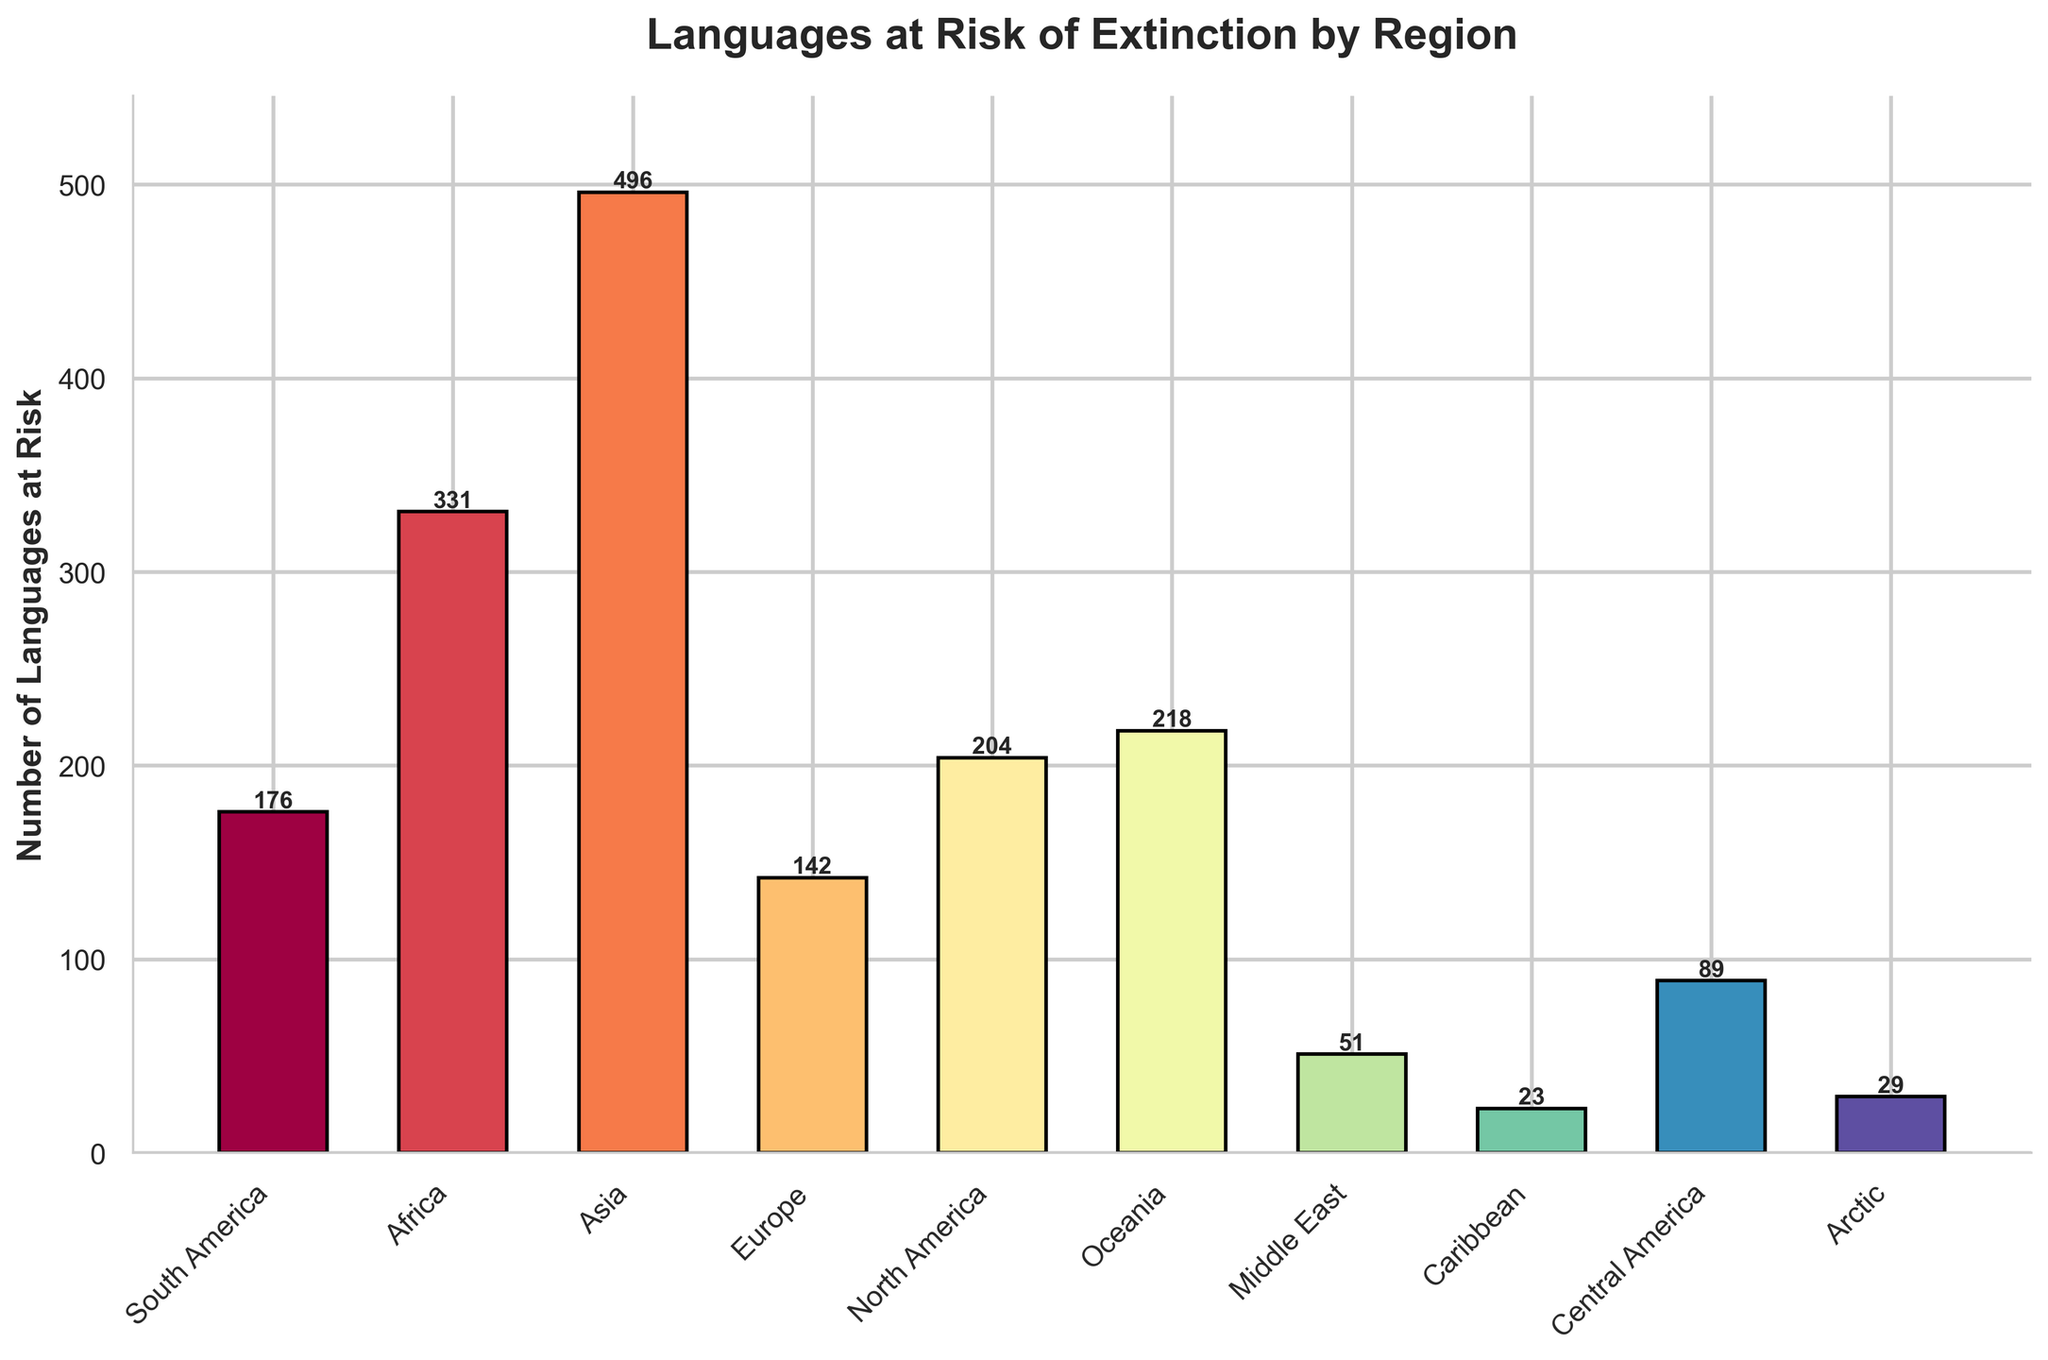Which region has the highest number of languages at risk of extinction? By analyzing the height of the bars in the chart, it is clear that Asia has the tallest bar representing the highest number of languages at risk.
Answer: Asia Which region has the lowest number of languages at risk of extinction? Among all the bars, the Caribbean region has the shortest bar, indicating it has the lowest number of languages at risk.
Answer: Caribbean How many more languages at risk are there in North America compared to Europe? The bar for North America reaches 204, and the bar for Europe reaches 142. Subtracting Europe’s number (142) from North America’s number (204) gives us 204 - 142 = 62.
Answer: 62 What is the total number of languages at risk in South America, Europe, and the Caribbean combined? By summing the number of languages at risk in South America (176), Europe (142), and the Caribbean (23), we get 176 + 142 + 23 = 341.
Answer: 341 How many regions have fewer than 100 languages at risk of extinction? By examining the heights of the bars, the regions with fewer than 100 languages at risk are the Middle East (51), the Caribbean (23), Central America (89), and the Arctic (29). That’s four regions.
Answer: 4 Which region has approximately twice the number of languages at risk as Europe? The number of languages at risk for Europe is 142. Approximately twice this number is 284. Among the listed regions, Africa has 331 languages at risk, which is closest to twice the number in Europe.
Answer: Africa What is the sum of languages at risk in Oceania and the Arctic? By adding the number of languages at risk in Oceania (218) and the Arctic (29), we get 218 + 29 = 247.
Answer: 247 Which three regions combined have the highest number of languages at risk? By summing the numbers for each possible combination, Asia (496), Africa (331), and Oceania (218) together give the highest sum of 496 + 331 + 218 = 1045.
Answer: Asia, Africa, and Oceania Which region has a number of languages at risk closest to 200? The regions with numbers near 200 languages at risk are North America with 204 and Oceania with 218. North America, being a bit closer to 200, has the closest number.
Answer: North America 